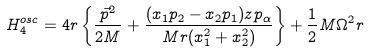Convert formula to latex. <formula><loc_0><loc_0><loc_500><loc_500>H ^ { o s c } _ { 4 } = 4 r \left \{ \frac { \vec { p } ^ { 2 } } { 2 M } + \frac { ( x _ { 1 } p _ { 2 } - x _ { 2 } p _ { 1 } ) z p _ { \alpha } } { M r ( x _ { 1 } ^ { 2 } + x _ { 2 } ^ { 2 } ) } \right \} + \frac { 1 } { 2 } M \Omega ^ { 2 } r</formula> 